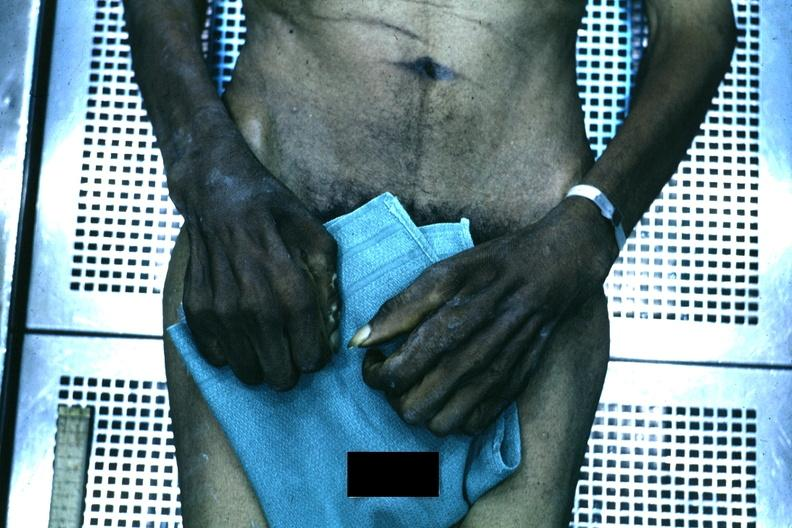s good example of muscle atrophy said to be due to syringomyelia?
Answer the question using a single word or phrase. Yes 